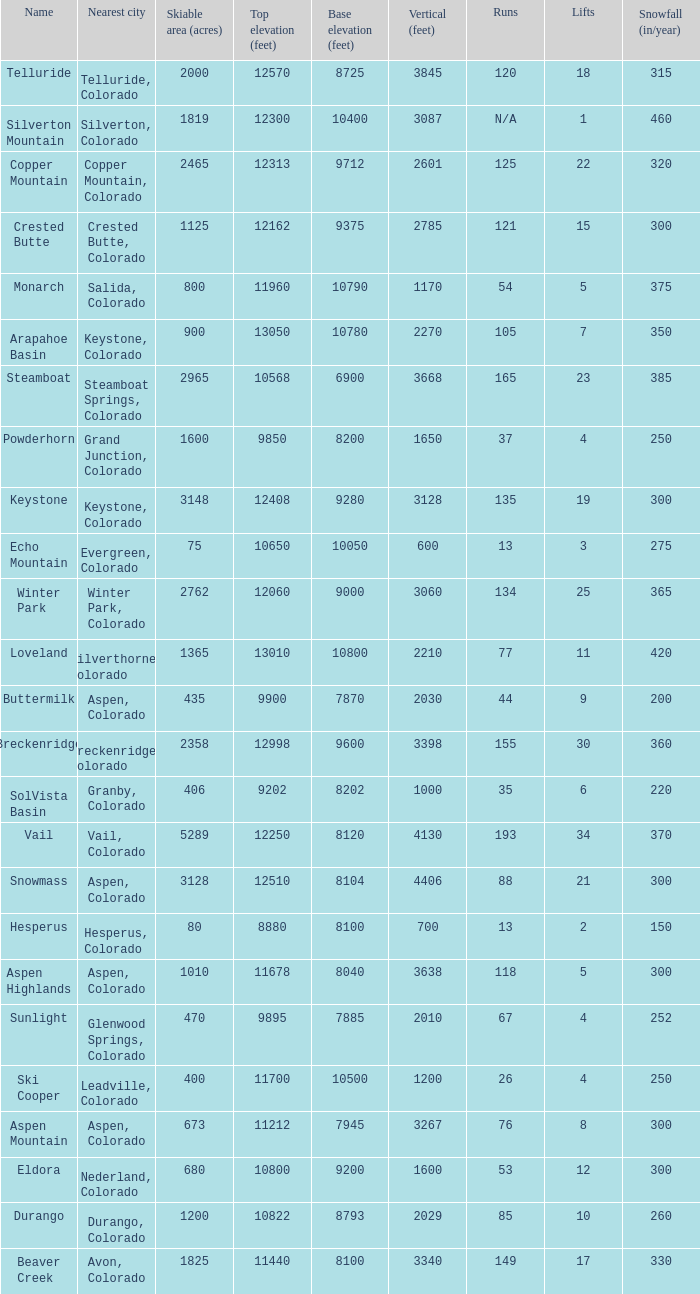What is the snowfall for ski resort Snowmass? 300.0. 